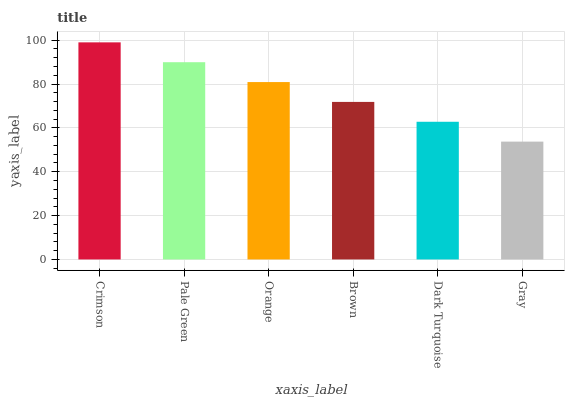Is Pale Green the minimum?
Answer yes or no. No. Is Pale Green the maximum?
Answer yes or no. No. Is Crimson greater than Pale Green?
Answer yes or no. Yes. Is Pale Green less than Crimson?
Answer yes or no. Yes. Is Pale Green greater than Crimson?
Answer yes or no. No. Is Crimson less than Pale Green?
Answer yes or no. No. Is Orange the high median?
Answer yes or no. Yes. Is Brown the low median?
Answer yes or no. Yes. Is Brown the high median?
Answer yes or no. No. Is Gray the low median?
Answer yes or no. No. 